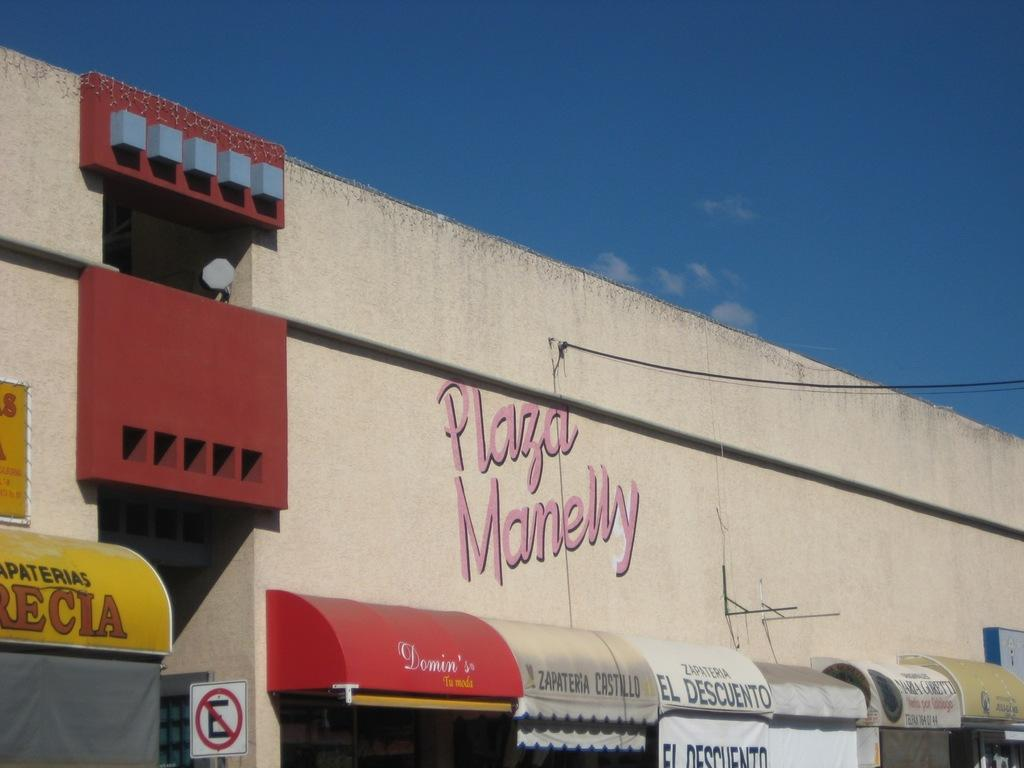What can be seen in the foreground of the image? In the foreground of the image, there are shops, banners, sign boards, text on a wall, and a rope. What is the condition of the sky in the image? The sky is visible in the image, and there are clouds present. Can you see a pen being used to sign a receipt in the image? There is no pen or receipt present in the image. Is there anyone shaking hands in the image? There is no handshake depicted in the image. 